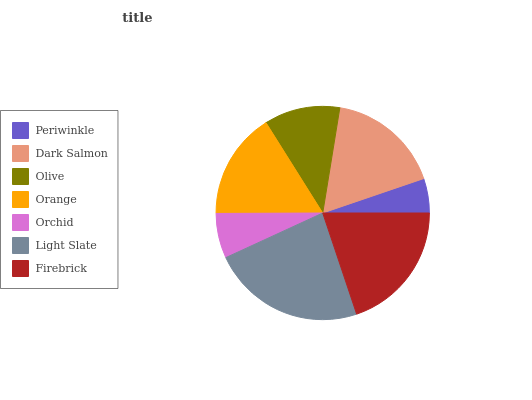Is Periwinkle the minimum?
Answer yes or no. Yes. Is Light Slate the maximum?
Answer yes or no. Yes. Is Dark Salmon the minimum?
Answer yes or no. No. Is Dark Salmon the maximum?
Answer yes or no. No. Is Dark Salmon greater than Periwinkle?
Answer yes or no. Yes. Is Periwinkle less than Dark Salmon?
Answer yes or no. Yes. Is Periwinkle greater than Dark Salmon?
Answer yes or no. No. Is Dark Salmon less than Periwinkle?
Answer yes or no. No. Is Orange the high median?
Answer yes or no. Yes. Is Orange the low median?
Answer yes or no. Yes. Is Firebrick the high median?
Answer yes or no. No. Is Firebrick the low median?
Answer yes or no. No. 